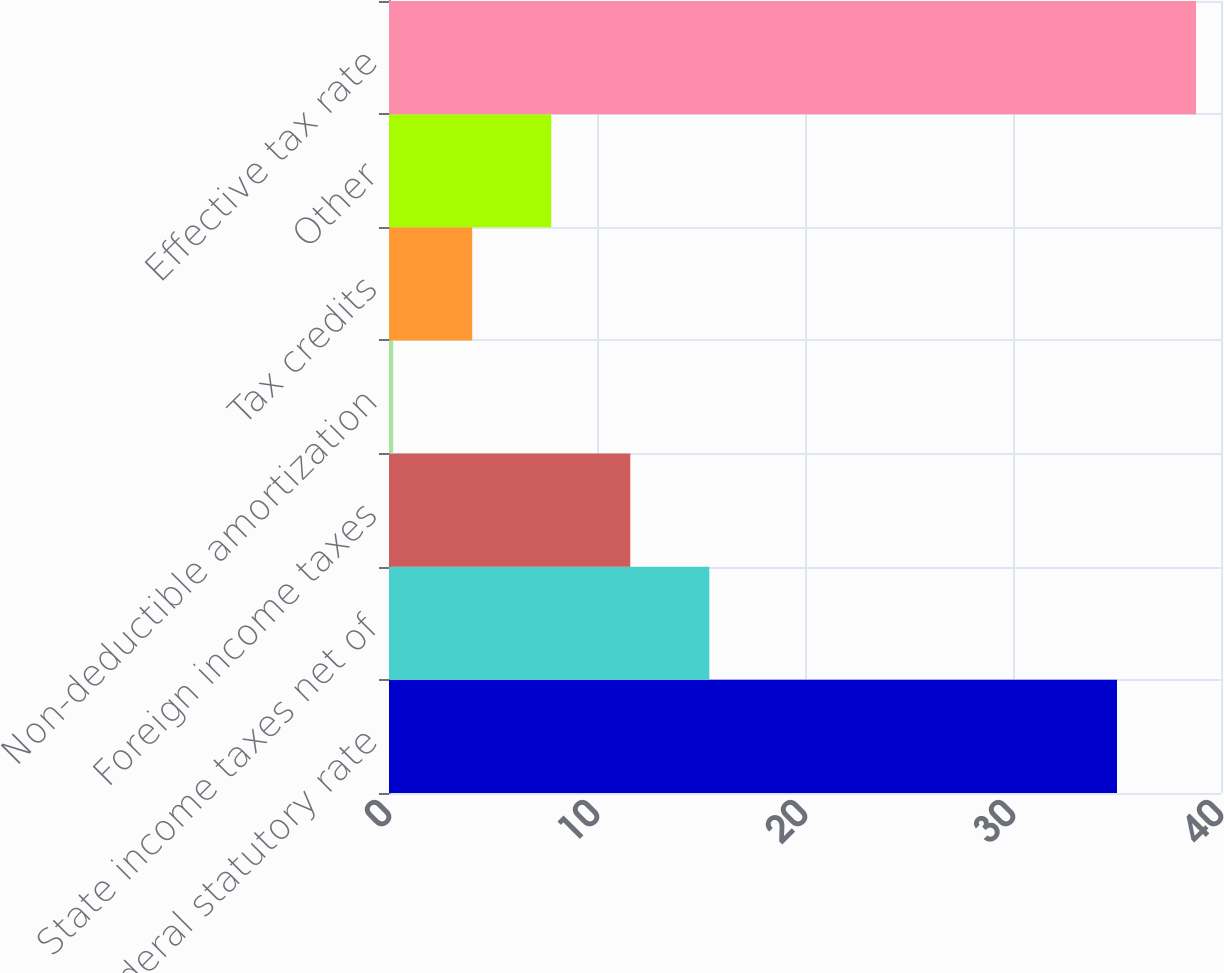Convert chart to OTSL. <chart><loc_0><loc_0><loc_500><loc_500><bar_chart><fcel>Federal statutory rate<fcel>State income taxes net of<fcel>Foreign income taxes<fcel>Non-deductible amortization<fcel>Tax credits<fcel>Other<fcel>Effective tax rate<nl><fcel>35<fcel>15.4<fcel>11.6<fcel>0.2<fcel>4<fcel>7.8<fcel>38.8<nl></chart> 